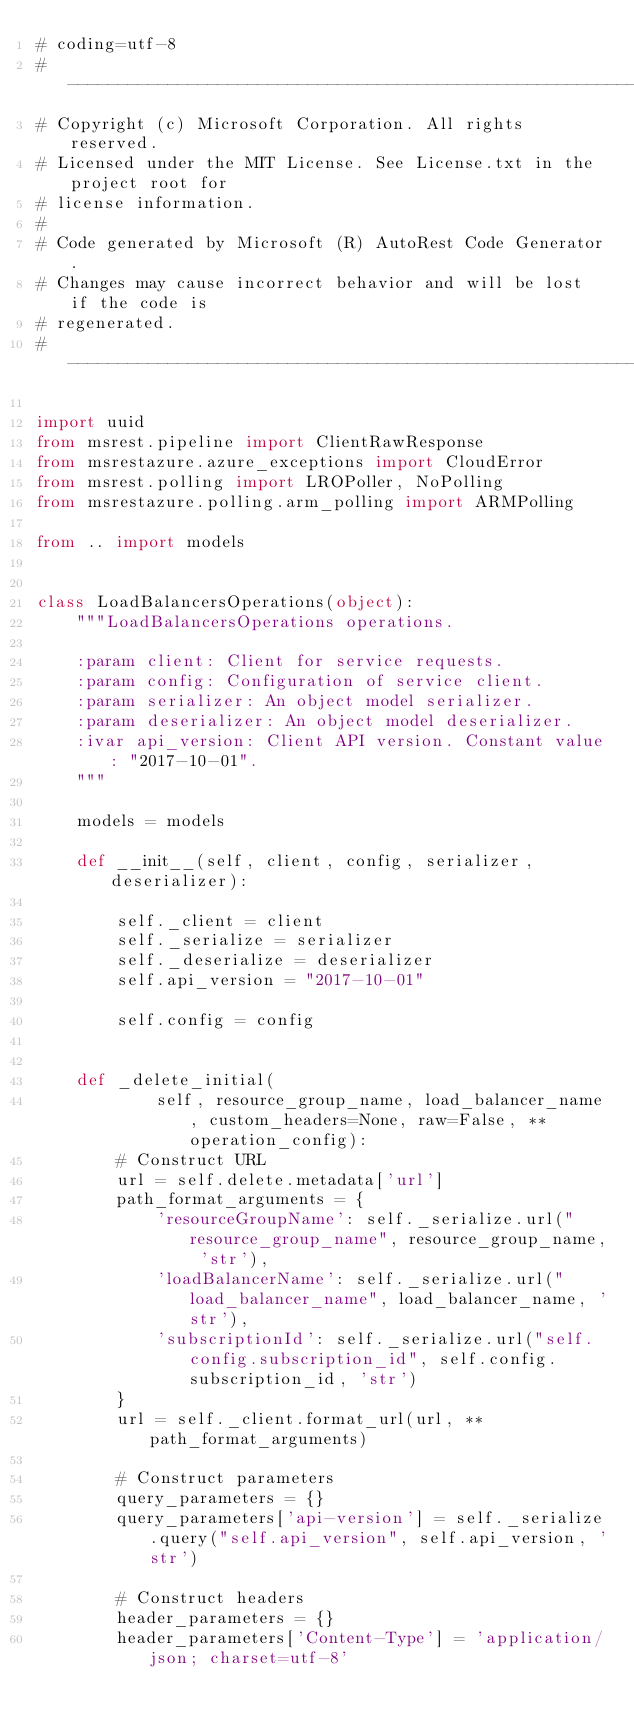Convert code to text. <code><loc_0><loc_0><loc_500><loc_500><_Python_># coding=utf-8
# --------------------------------------------------------------------------
# Copyright (c) Microsoft Corporation. All rights reserved.
# Licensed under the MIT License. See License.txt in the project root for
# license information.
#
# Code generated by Microsoft (R) AutoRest Code Generator.
# Changes may cause incorrect behavior and will be lost if the code is
# regenerated.
# --------------------------------------------------------------------------

import uuid
from msrest.pipeline import ClientRawResponse
from msrestazure.azure_exceptions import CloudError
from msrest.polling import LROPoller, NoPolling
from msrestazure.polling.arm_polling import ARMPolling

from .. import models


class LoadBalancersOperations(object):
    """LoadBalancersOperations operations.

    :param client: Client for service requests.
    :param config: Configuration of service client.
    :param serializer: An object model serializer.
    :param deserializer: An object model deserializer.
    :ivar api_version: Client API version. Constant value: "2017-10-01".
    """

    models = models

    def __init__(self, client, config, serializer, deserializer):

        self._client = client
        self._serialize = serializer
        self._deserialize = deserializer
        self.api_version = "2017-10-01"

        self.config = config


    def _delete_initial(
            self, resource_group_name, load_balancer_name, custom_headers=None, raw=False, **operation_config):
        # Construct URL
        url = self.delete.metadata['url']
        path_format_arguments = {
            'resourceGroupName': self._serialize.url("resource_group_name", resource_group_name, 'str'),
            'loadBalancerName': self._serialize.url("load_balancer_name", load_balancer_name, 'str'),
            'subscriptionId': self._serialize.url("self.config.subscription_id", self.config.subscription_id, 'str')
        }
        url = self._client.format_url(url, **path_format_arguments)

        # Construct parameters
        query_parameters = {}
        query_parameters['api-version'] = self._serialize.query("self.api_version", self.api_version, 'str')

        # Construct headers
        header_parameters = {}
        header_parameters['Content-Type'] = 'application/json; charset=utf-8'</code> 